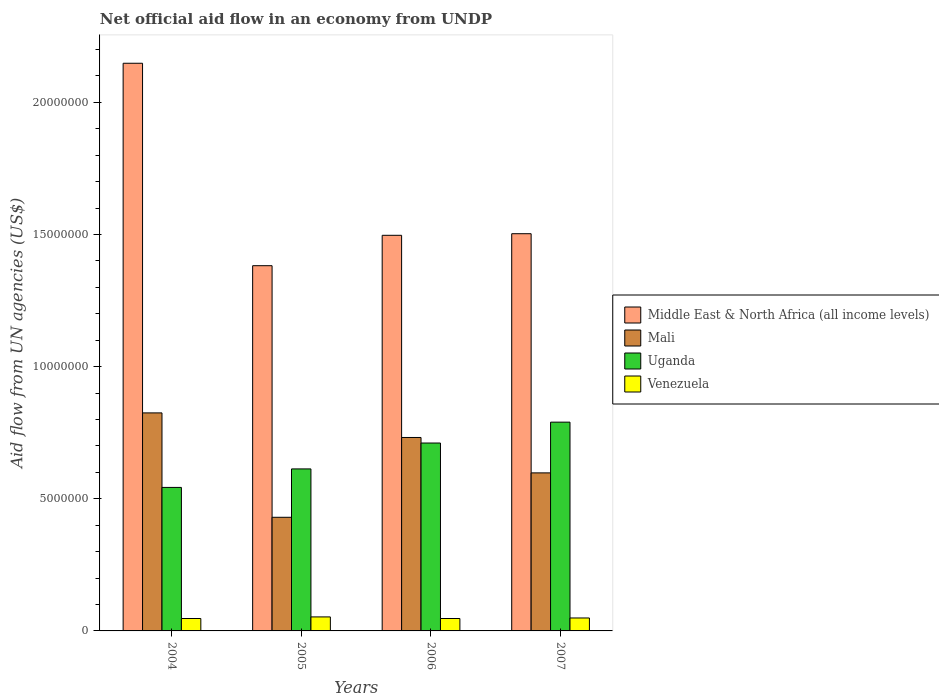How many different coloured bars are there?
Your answer should be very brief. 4. Are the number of bars per tick equal to the number of legend labels?
Ensure brevity in your answer.  Yes. How many bars are there on the 2nd tick from the left?
Make the answer very short. 4. What is the label of the 1st group of bars from the left?
Your answer should be compact. 2004. In how many cases, is the number of bars for a given year not equal to the number of legend labels?
Keep it short and to the point. 0. What is the net official aid flow in Venezuela in 2005?
Keep it short and to the point. 5.30e+05. Across all years, what is the maximum net official aid flow in Venezuela?
Your answer should be compact. 5.30e+05. Across all years, what is the minimum net official aid flow in Middle East & North Africa (all income levels)?
Ensure brevity in your answer.  1.38e+07. In which year was the net official aid flow in Uganda maximum?
Provide a short and direct response. 2007. In which year was the net official aid flow in Middle East & North Africa (all income levels) minimum?
Your response must be concise. 2005. What is the total net official aid flow in Mali in the graph?
Your answer should be compact. 2.58e+07. What is the difference between the net official aid flow in Middle East & North Africa (all income levels) in 2004 and that in 2007?
Provide a succinct answer. 6.45e+06. What is the difference between the net official aid flow in Venezuela in 2007 and the net official aid flow in Mali in 2005?
Offer a terse response. -3.81e+06. In the year 2004, what is the difference between the net official aid flow in Mali and net official aid flow in Venezuela?
Ensure brevity in your answer.  7.78e+06. In how many years, is the net official aid flow in Middle East & North Africa (all income levels) greater than 19000000 US$?
Provide a short and direct response. 1. What is the ratio of the net official aid flow in Middle East & North Africa (all income levels) in 2005 to that in 2007?
Keep it short and to the point. 0.92. Is the difference between the net official aid flow in Mali in 2004 and 2007 greater than the difference between the net official aid flow in Venezuela in 2004 and 2007?
Ensure brevity in your answer.  Yes. What is the difference between the highest and the second highest net official aid flow in Uganda?
Your response must be concise. 7.90e+05. What is the difference between the highest and the lowest net official aid flow in Middle East & North Africa (all income levels)?
Provide a succinct answer. 7.66e+06. Is the sum of the net official aid flow in Middle East & North Africa (all income levels) in 2004 and 2007 greater than the maximum net official aid flow in Mali across all years?
Give a very brief answer. Yes. Is it the case that in every year, the sum of the net official aid flow in Mali and net official aid flow in Venezuela is greater than the sum of net official aid flow in Middle East & North Africa (all income levels) and net official aid flow in Uganda?
Offer a very short reply. Yes. What does the 1st bar from the left in 2005 represents?
Provide a succinct answer. Middle East & North Africa (all income levels). What does the 4th bar from the right in 2005 represents?
Your answer should be compact. Middle East & North Africa (all income levels). Is it the case that in every year, the sum of the net official aid flow in Venezuela and net official aid flow in Middle East & North Africa (all income levels) is greater than the net official aid flow in Uganda?
Your response must be concise. Yes. Are all the bars in the graph horizontal?
Keep it short and to the point. No. How many years are there in the graph?
Your answer should be compact. 4. Are the values on the major ticks of Y-axis written in scientific E-notation?
Ensure brevity in your answer.  No. How are the legend labels stacked?
Your answer should be very brief. Vertical. What is the title of the graph?
Make the answer very short. Net official aid flow in an economy from UNDP. What is the label or title of the Y-axis?
Provide a short and direct response. Aid flow from UN agencies (US$). What is the Aid flow from UN agencies (US$) of Middle East & North Africa (all income levels) in 2004?
Provide a short and direct response. 2.15e+07. What is the Aid flow from UN agencies (US$) in Mali in 2004?
Offer a terse response. 8.25e+06. What is the Aid flow from UN agencies (US$) of Uganda in 2004?
Make the answer very short. 5.43e+06. What is the Aid flow from UN agencies (US$) of Venezuela in 2004?
Give a very brief answer. 4.70e+05. What is the Aid flow from UN agencies (US$) of Middle East & North Africa (all income levels) in 2005?
Provide a succinct answer. 1.38e+07. What is the Aid flow from UN agencies (US$) of Mali in 2005?
Your answer should be compact. 4.30e+06. What is the Aid flow from UN agencies (US$) of Uganda in 2005?
Ensure brevity in your answer.  6.13e+06. What is the Aid flow from UN agencies (US$) of Venezuela in 2005?
Your answer should be very brief. 5.30e+05. What is the Aid flow from UN agencies (US$) of Middle East & North Africa (all income levels) in 2006?
Your response must be concise. 1.50e+07. What is the Aid flow from UN agencies (US$) in Mali in 2006?
Your answer should be compact. 7.32e+06. What is the Aid flow from UN agencies (US$) in Uganda in 2006?
Your response must be concise. 7.11e+06. What is the Aid flow from UN agencies (US$) of Venezuela in 2006?
Provide a short and direct response. 4.70e+05. What is the Aid flow from UN agencies (US$) of Middle East & North Africa (all income levels) in 2007?
Offer a very short reply. 1.50e+07. What is the Aid flow from UN agencies (US$) in Mali in 2007?
Provide a succinct answer. 5.98e+06. What is the Aid flow from UN agencies (US$) of Uganda in 2007?
Make the answer very short. 7.90e+06. Across all years, what is the maximum Aid flow from UN agencies (US$) in Middle East & North Africa (all income levels)?
Offer a terse response. 2.15e+07. Across all years, what is the maximum Aid flow from UN agencies (US$) of Mali?
Keep it short and to the point. 8.25e+06. Across all years, what is the maximum Aid flow from UN agencies (US$) in Uganda?
Make the answer very short. 7.90e+06. Across all years, what is the maximum Aid flow from UN agencies (US$) in Venezuela?
Your response must be concise. 5.30e+05. Across all years, what is the minimum Aid flow from UN agencies (US$) of Middle East & North Africa (all income levels)?
Ensure brevity in your answer.  1.38e+07. Across all years, what is the minimum Aid flow from UN agencies (US$) in Mali?
Provide a succinct answer. 4.30e+06. Across all years, what is the minimum Aid flow from UN agencies (US$) in Uganda?
Offer a terse response. 5.43e+06. Across all years, what is the minimum Aid flow from UN agencies (US$) in Venezuela?
Provide a short and direct response. 4.70e+05. What is the total Aid flow from UN agencies (US$) in Middle East & North Africa (all income levels) in the graph?
Offer a terse response. 6.53e+07. What is the total Aid flow from UN agencies (US$) of Mali in the graph?
Your response must be concise. 2.58e+07. What is the total Aid flow from UN agencies (US$) in Uganda in the graph?
Your answer should be compact. 2.66e+07. What is the total Aid flow from UN agencies (US$) of Venezuela in the graph?
Give a very brief answer. 1.96e+06. What is the difference between the Aid flow from UN agencies (US$) in Middle East & North Africa (all income levels) in 2004 and that in 2005?
Ensure brevity in your answer.  7.66e+06. What is the difference between the Aid flow from UN agencies (US$) of Mali in 2004 and that in 2005?
Your answer should be compact. 3.95e+06. What is the difference between the Aid flow from UN agencies (US$) of Uganda in 2004 and that in 2005?
Keep it short and to the point. -7.00e+05. What is the difference between the Aid flow from UN agencies (US$) in Middle East & North Africa (all income levels) in 2004 and that in 2006?
Your response must be concise. 6.51e+06. What is the difference between the Aid flow from UN agencies (US$) in Mali in 2004 and that in 2006?
Provide a short and direct response. 9.30e+05. What is the difference between the Aid flow from UN agencies (US$) in Uganda in 2004 and that in 2006?
Provide a short and direct response. -1.68e+06. What is the difference between the Aid flow from UN agencies (US$) in Venezuela in 2004 and that in 2006?
Offer a terse response. 0. What is the difference between the Aid flow from UN agencies (US$) of Middle East & North Africa (all income levels) in 2004 and that in 2007?
Provide a short and direct response. 6.45e+06. What is the difference between the Aid flow from UN agencies (US$) of Mali in 2004 and that in 2007?
Make the answer very short. 2.27e+06. What is the difference between the Aid flow from UN agencies (US$) in Uganda in 2004 and that in 2007?
Your answer should be compact. -2.47e+06. What is the difference between the Aid flow from UN agencies (US$) in Venezuela in 2004 and that in 2007?
Provide a succinct answer. -2.00e+04. What is the difference between the Aid flow from UN agencies (US$) of Middle East & North Africa (all income levels) in 2005 and that in 2006?
Make the answer very short. -1.15e+06. What is the difference between the Aid flow from UN agencies (US$) in Mali in 2005 and that in 2006?
Provide a short and direct response. -3.02e+06. What is the difference between the Aid flow from UN agencies (US$) in Uganda in 2005 and that in 2006?
Make the answer very short. -9.80e+05. What is the difference between the Aid flow from UN agencies (US$) of Middle East & North Africa (all income levels) in 2005 and that in 2007?
Provide a succinct answer. -1.21e+06. What is the difference between the Aid flow from UN agencies (US$) in Mali in 2005 and that in 2007?
Offer a very short reply. -1.68e+06. What is the difference between the Aid flow from UN agencies (US$) in Uganda in 2005 and that in 2007?
Ensure brevity in your answer.  -1.77e+06. What is the difference between the Aid flow from UN agencies (US$) in Mali in 2006 and that in 2007?
Keep it short and to the point. 1.34e+06. What is the difference between the Aid flow from UN agencies (US$) in Uganda in 2006 and that in 2007?
Your answer should be compact. -7.90e+05. What is the difference between the Aid flow from UN agencies (US$) of Middle East & North Africa (all income levels) in 2004 and the Aid flow from UN agencies (US$) of Mali in 2005?
Make the answer very short. 1.72e+07. What is the difference between the Aid flow from UN agencies (US$) of Middle East & North Africa (all income levels) in 2004 and the Aid flow from UN agencies (US$) of Uganda in 2005?
Provide a succinct answer. 1.54e+07. What is the difference between the Aid flow from UN agencies (US$) in Middle East & North Africa (all income levels) in 2004 and the Aid flow from UN agencies (US$) in Venezuela in 2005?
Offer a terse response. 2.10e+07. What is the difference between the Aid flow from UN agencies (US$) in Mali in 2004 and the Aid flow from UN agencies (US$) in Uganda in 2005?
Your response must be concise. 2.12e+06. What is the difference between the Aid flow from UN agencies (US$) in Mali in 2004 and the Aid flow from UN agencies (US$) in Venezuela in 2005?
Offer a terse response. 7.72e+06. What is the difference between the Aid flow from UN agencies (US$) of Uganda in 2004 and the Aid flow from UN agencies (US$) of Venezuela in 2005?
Provide a short and direct response. 4.90e+06. What is the difference between the Aid flow from UN agencies (US$) in Middle East & North Africa (all income levels) in 2004 and the Aid flow from UN agencies (US$) in Mali in 2006?
Give a very brief answer. 1.42e+07. What is the difference between the Aid flow from UN agencies (US$) in Middle East & North Africa (all income levels) in 2004 and the Aid flow from UN agencies (US$) in Uganda in 2006?
Your answer should be compact. 1.44e+07. What is the difference between the Aid flow from UN agencies (US$) of Middle East & North Africa (all income levels) in 2004 and the Aid flow from UN agencies (US$) of Venezuela in 2006?
Offer a terse response. 2.10e+07. What is the difference between the Aid flow from UN agencies (US$) in Mali in 2004 and the Aid flow from UN agencies (US$) in Uganda in 2006?
Your answer should be compact. 1.14e+06. What is the difference between the Aid flow from UN agencies (US$) in Mali in 2004 and the Aid flow from UN agencies (US$) in Venezuela in 2006?
Your answer should be compact. 7.78e+06. What is the difference between the Aid flow from UN agencies (US$) of Uganda in 2004 and the Aid flow from UN agencies (US$) of Venezuela in 2006?
Make the answer very short. 4.96e+06. What is the difference between the Aid flow from UN agencies (US$) in Middle East & North Africa (all income levels) in 2004 and the Aid flow from UN agencies (US$) in Mali in 2007?
Make the answer very short. 1.55e+07. What is the difference between the Aid flow from UN agencies (US$) in Middle East & North Africa (all income levels) in 2004 and the Aid flow from UN agencies (US$) in Uganda in 2007?
Provide a short and direct response. 1.36e+07. What is the difference between the Aid flow from UN agencies (US$) of Middle East & North Africa (all income levels) in 2004 and the Aid flow from UN agencies (US$) of Venezuela in 2007?
Offer a very short reply. 2.10e+07. What is the difference between the Aid flow from UN agencies (US$) of Mali in 2004 and the Aid flow from UN agencies (US$) of Venezuela in 2007?
Make the answer very short. 7.76e+06. What is the difference between the Aid flow from UN agencies (US$) of Uganda in 2004 and the Aid flow from UN agencies (US$) of Venezuela in 2007?
Your answer should be compact. 4.94e+06. What is the difference between the Aid flow from UN agencies (US$) of Middle East & North Africa (all income levels) in 2005 and the Aid flow from UN agencies (US$) of Mali in 2006?
Give a very brief answer. 6.50e+06. What is the difference between the Aid flow from UN agencies (US$) in Middle East & North Africa (all income levels) in 2005 and the Aid flow from UN agencies (US$) in Uganda in 2006?
Give a very brief answer. 6.71e+06. What is the difference between the Aid flow from UN agencies (US$) of Middle East & North Africa (all income levels) in 2005 and the Aid flow from UN agencies (US$) of Venezuela in 2006?
Offer a very short reply. 1.34e+07. What is the difference between the Aid flow from UN agencies (US$) of Mali in 2005 and the Aid flow from UN agencies (US$) of Uganda in 2006?
Offer a terse response. -2.81e+06. What is the difference between the Aid flow from UN agencies (US$) of Mali in 2005 and the Aid flow from UN agencies (US$) of Venezuela in 2006?
Provide a succinct answer. 3.83e+06. What is the difference between the Aid flow from UN agencies (US$) in Uganda in 2005 and the Aid flow from UN agencies (US$) in Venezuela in 2006?
Give a very brief answer. 5.66e+06. What is the difference between the Aid flow from UN agencies (US$) in Middle East & North Africa (all income levels) in 2005 and the Aid flow from UN agencies (US$) in Mali in 2007?
Offer a very short reply. 7.84e+06. What is the difference between the Aid flow from UN agencies (US$) of Middle East & North Africa (all income levels) in 2005 and the Aid flow from UN agencies (US$) of Uganda in 2007?
Keep it short and to the point. 5.92e+06. What is the difference between the Aid flow from UN agencies (US$) of Middle East & North Africa (all income levels) in 2005 and the Aid flow from UN agencies (US$) of Venezuela in 2007?
Make the answer very short. 1.33e+07. What is the difference between the Aid flow from UN agencies (US$) of Mali in 2005 and the Aid flow from UN agencies (US$) of Uganda in 2007?
Provide a short and direct response. -3.60e+06. What is the difference between the Aid flow from UN agencies (US$) in Mali in 2005 and the Aid flow from UN agencies (US$) in Venezuela in 2007?
Provide a short and direct response. 3.81e+06. What is the difference between the Aid flow from UN agencies (US$) in Uganda in 2005 and the Aid flow from UN agencies (US$) in Venezuela in 2007?
Your answer should be very brief. 5.64e+06. What is the difference between the Aid flow from UN agencies (US$) of Middle East & North Africa (all income levels) in 2006 and the Aid flow from UN agencies (US$) of Mali in 2007?
Give a very brief answer. 8.99e+06. What is the difference between the Aid flow from UN agencies (US$) in Middle East & North Africa (all income levels) in 2006 and the Aid flow from UN agencies (US$) in Uganda in 2007?
Make the answer very short. 7.07e+06. What is the difference between the Aid flow from UN agencies (US$) in Middle East & North Africa (all income levels) in 2006 and the Aid flow from UN agencies (US$) in Venezuela in 2007?
Offer a very short reply. 1.45e+07. What is the difference between the Aid flow from UN agencies (US$) of Mali in 2006 and the Aid flow from UN agencies (US$) of Uganda in 2007?
Give a very brief answer. -5.80e+05. What is the difference between the Aid flow from UN agencies (US$) in Mali in 2006 and the Aid flow from UN agencies (US$) in Venezuela in 2007?
Ensure brevity in your answer.  6.83e+06. What is the difference between the Aid flow from UN agencies (US$) in Uganda in 2006 and the Aid flow from UN agencies (US$) in Venezuela in 2007?
Make the answer very short. 6.62e+06. What is the average Aid flow from UN agencies (US$) of Middle East & North Africa (all income levels) per year?
Your answer should be compact. 1.63e+07. What is the average Aid flow from UN agencies (US$) of Mali per year?
Keep it short and to the point. 6.46e+06. What is the average Aid flow from UN agencies (US$) in Uganda per year?
Provide a succinct answer. 6.64e+06. What is the average Aid flow from UN agencies (US$) of Venezuela per year?
Make the answer very short. 4.90e+05. In the year 2004, what is the difference between the Aid flow from UN agencies (US$) of Middle East & North Africa (all income levels) and Aid flow from UN agencies (US$) of Mali?
Your answer should be very brief. 1.32e+07. In the year 2004, what is the difference between the Aid flow from UN agencies (US$) in Middle East & North Africa (all income levels) and Aid flow from UN agencies (US$) in Uganda?
Offer a terse response. 1.60e+07. In the year 2004, what is the difference between the Aid flow from UN agencies (US$) in Middle East & North Africa (all income levels) and Aid flow from UN agencies (US$) in Venezuela?
Provide a short and direct response. 2.10e+07. In the year 2004, what is the difference between the Aid flow from UN agencies (US$) of Mali and Aid flow from UN agencies (US$) of Uganda?
Make the answer very short. 2.82e+06. In the year 2004, what is the difference between the Aid flow from UN agencies (US$) in Mali and Aid flow from UN agencies (US$) in Venezuela?
Make the answer very short. 7.78e+06. In the year 2004, what is the difference between the Aid flow from UN agencies (US$) of Uganda and Aid flow from UN agencies (US$) of Venezuela?
Keep it short and to the point. 4.96e+06. In the year 2005, what is the difference between the Aid flow from UN agencies (US$) in Middle East & North Africa (all income levels) and Aid flow from UN agencies (US$) in Mali?
Provide a short and direct response. 9.52e+06. In the year 2005, what is the difference between the Aid flow from UN agencies (US$) in Middle East & North Africa (all income levels) and Aid flow from UN agencies (US$) in Uganda?
Your answer should be compact. 7.69e+06. In the year 2005, what is the difference between the Aid flow from UN agencies (US$) of Middle East & North Africa (all income levels) and Aid flow from UN agencies (US$) of Venezuela?
Offer a terse response. 1.33e+07. In the year 2005, what is the difference between the Aid flow from UN agencies (US$) of Mali and Aid flow from UN agencies (US$) of Uganda?
Your answer should be compact. -1.83e+06. In the year 2005, what is the difference between the Aid flow from UN agencies (US$) in Mali and Aid flow from UN agencies (US$) in Venezuela?
Give a very brief answer. 3.77e+06. In the year 2005, what is the difference between the Aid flow from UN agencies (US$) of Uganda and Aid flow from UN agencies (US$) of Venezuela?
Keep it short and to the point. 5.60e+06. In the year 2006, what is the difference between the Aid flow from UN agencies (US$) in Middle East & North Africa (all income levels) and Aid flow from UN agencies (US$) in Mali?
Your answer should be compact. 7.65e+06. In the year 2006, what is the difference between the Aid flow from UN agencies (US$) of Middle East & North Africa (all income levels) and Aid flow from UN agencies (US$) of Uganda?
Offer a terse response. 7.86e+06. In the year 2006, what is the difference between the Aid flow from UN agencies (US$) of Middle East & North Africa (all income levels) and Aid flow from UN agencies (US$) of Venezuela?
Your response must be concise. 1.45e+07. In the year 2006, what is the difference between the Aid flow from UN agencies (US$) of Mali and Aid flow from UN agencies (US$) of Uganda?
Your response must be concise. 2.10e+05. In the year 2006, what is the difference between the Aid flow from UN agencies (US$) of Mali and Aid flow from UN agencies (US$) of Venezuela?
Make the answer very short. 6.85e+06. In the year 2006, what is the difference between the Aid flow from UN agencies (US$) in Uganda and Aid flow from UN agencies (US$) in Venezuela?
Your answer should be very brief. 6.64e+06. In the year 2007, what is the difference between the Aid flow from UN agencies (US$) of Middle East & North Africa (all income levels) and Aid flow from UN agencies (US$) of Mali?
Keep it short and to the point. 9.05e+06. In the year 2007, what is the difference between the Aid flow from UN agencies (US$) of Middle East & North Africa (all income levels) and Aid flow from UN agencies (US$) of Uganda?
Your response must be concise. 7.13e+06. In the year 2007, what is the difference between the Aid flow from UN agencies (US$) of Middle East & North Africa (all income levels) and Aid flow from UN agencies (US$) of Venezuela?
Keep it short and to the point. 1.45e+07. In the year 2007, what is the difference between the Aid flow from UN agencies (US$) in Mali and Aid flow from UN agencies (US$) in Uganda?
Ensure brevity in your answer.  -1.92e+06. In the year 2007, what is the difference between the Aid flow from UN agencies (US$) of Mali and Aid flow from UN agencies (US$) of Venezuela?
Provide a succinct answer. 5.49e+06. In the year 2007, what is the difference between the Aid flow from UN agencies (US$) in Uganda and Aid flow from UN agencies (US$) in Venezuela?
Your answer should be compact. 7.41e+06. What is the ratio of the Aid flow from UN agencies (US$) of Middle East & North Africa (all income levels) in 2004 to that in 2005?
Your response must be concise. 1.55. What is the ratio of the Aid flow from UN agencies (US$) of Mali in 2004 to that in 2005?
Give a very brief answer. 1.92. What is the ratio of the Aid flow from UN agencies (US$) of Uganda in 2004 to that in 2005?
Offer a very short reply. 0.89. What is the ratio of the Aid flow from UN agencies (US$) in Venezuela in 2004 to that in 2005?
Offer a terse response. 0.89. What is the ratio of the Aid flow from UN agencies (US$) of Middle East & North Africa (all income levels) in 2004 to that in 2006?
Offer a very short reply. 1.43. What is the ratio of the Aid flow from UN agencies (US$) of Mali in 2004 to that in 2006?
Make the answer very short. 1.13. What is the ratio of the Aid flow from UN agencies (US$) in Uganda in 2004 to that in 2006?
Your answer should be very brief. 0.76. What is the ratio of the Aid flow from UN agencies (US$) of Middle East & North Africa (all income levels) in 2004 to that in 2007?
Keep it short and to the point. 1.43. What is the ratio of the Aid flow from UN agencies (US$) in Mali in 2004 to that in 2007?
Your answer should be very brief. 1.38. What is the ratio of the Aid flow from UN agencies (US$) in Uganda in 2004 to that in 2007?
Provide a succinct answer. 0.69. What is the ratio of the Aid flow from UN agencies (US$) of Venezuela in 2004 to that in 2007?
Your response must be concise. 0.96. What is the ratio of the Aid flow from UN agencies (US$) of Middle East & North Africa (all income levels) in 2005 to that in 2006?
Ensure brevity in your answer.  0.92. What is the ratio of the Aid flow from UN agencies (US$) of Mali in 2005 to that in 2006?
Your response must be concise. 0.59. What is the ratio of the Aid flow from UN agencies (US$) in Uganda in 2005 to that in 2006?
Provide a succinct answer. 0.86. What is the ratio of the Aid flow from UN agencies (US$) in Venezuela in 2005 to that in 2006?
Provide a short and direct response. 1.13. What is the ratio of the Aid flow from UN agencies (US$) of Middle East & North Africa (all income levels) in 2005 to that in 2007?
Your response must be concise. 0.92. What is the ratio of the Aid flow from UN agencies (US$) of Mali in 2005 to that in 2007?
Offer a terse response. 0.72. What is the ratio of the Aid flow from UN agencies (US$) in Uganda in 2005 to that in 2007?
Provide a short and direct response. 0.78. What is the ratio of the Aid flow from UN agencies (US$) of Venezuela in 2005 to that in 2007?
Provide a succinct answer. 1.08. What is the ratio of the Aid flow from UN agencies (US$) of Mali in 2006 to that in 2007?
Provide a succinct answer. 1.22. What is the ratio of the Aid flow from UN agencies (US$) in Uganda in 2006 to that in 2007?
Offer a very short reply. 0.9. What is the ratio of the Aid flow from UN agencies (US$) in Venezuela in 2006 to that in 2007?
Your response must be concise. 0.96. What is the difference between the highest and the second highest Aid flow from UN agencies (US$) of Middle East & North Africa (all income levels)?
Offer a terse response. 6.45e+06. What is the difference between the highest and the second highest Aid flow from UN agencies (US$) of Mali?
Your answer should be compact. 9.30e+05. What is the difference between the highest and the second highest Aid flow from UN agencies (US$) in Uganda?
Offer a very short reply. 7.90e+05. What is the difference between the highest and the second highest Aid flow from UN agencies (US$) of Venezuela?
Ensure brevity in your answer.  4.00e+04. What is the difference between the highest and the lowest Aid flow from UN agencies (US$) in Middle East & North Africa (all income levels)?
Ensure brevity in your answer.  7.66e+06. What is the difference between the highest and the lowest Aid flow from UN agencies (US$) in Mali?
Make the answer very short. 3.95e+06. What is the difference between the highest and the lowest Aid flow from UN agencies (US$) in Uganda?
Offer a terse response. 2.47e+06. What is the difference between the highest and the lowest Aid flow from UN agencies (US$) in Venezuela?
Provide a short and direct response. 6.00e+04. 